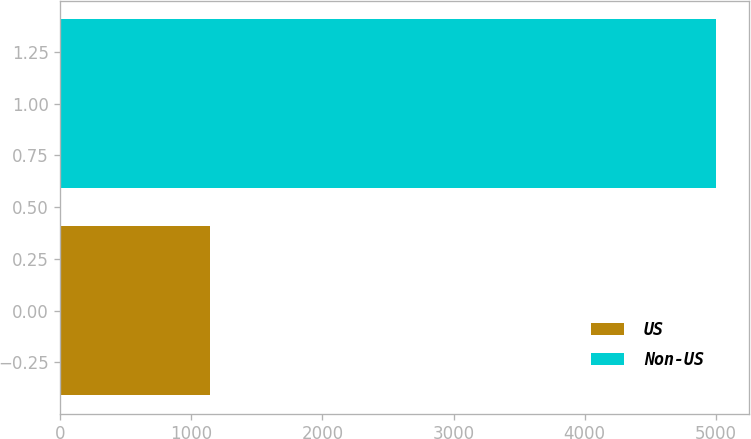Convert chart. <chart><loc_0><loc_0><loc_500><loc_500><bar_chart><fcel>US<fcel>Non-US<nl><fcel>1144<fcel>5004<nl></chart> 